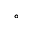<formula> <loc_0><loc_0><loc_500><loc_500>^ { \circ }</formula> 